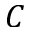<formula> <loc_0><loc_0><loc_500><loc_500>C</formula> 